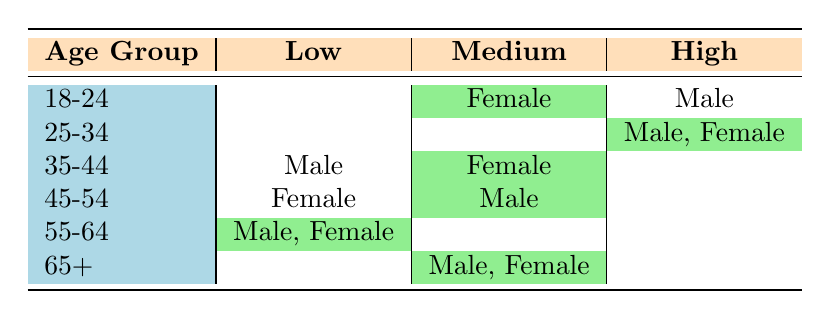What percentage of 18-24-year-old females have a medium awareness level? Referring to the table, it shows that only one female in the 18-24 age group has a medium awareness level. To find the percentage, we divide this by the total number of individuals in that age group (which is 2: 1 male and 1 female), then multiply by 100: (1/2) * 100 = 50%.
Answer: 50% Which age group has the highest number of individuals reporting high awareness? From the table, both the 25-34 age group has two individuals reporting high awareness (one male, one female). Checking other age groups, none have more than two. Therefore, the age group with the highest number of individuals reporting high awareness is 25-34.
Answer: 25-34 Is there any male in the 35-44 age group with a high awareness level? The table indicates that the 35-44 age group consists of one male with a low awareness level and a female with medium awareness. Thus, there is no male with a high awareness level in the 35-44 age group.
Answer: No What is the total count of individuals with low awareness across all age groups? In the table, we can sum the number of individuals with low awareness levels: 1 (35-44 Male) + 1 (45-54 Female) + 2 (55-64 Male and Female) = 4. Therefore, the total count of individuals with low awareness is four.
Answer: 4 In which demographic does the highest number of respondents report medium awareness? By analyzing the table, the demographic of 65+ has the highest number of individuals reporting medium awareness (2: one male, one female). The other age groups don’t exceed this number but may report medium awareness individually.
Answer: 65+ 